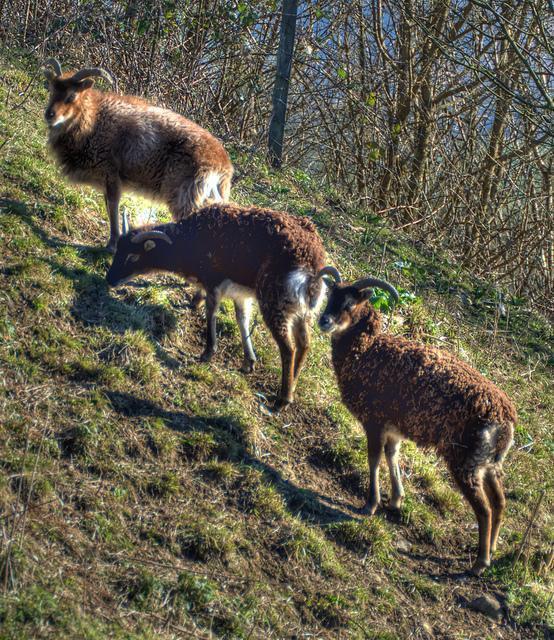How many goats do you see?
Give a very brief answer. 3. How many sheep are in the photo?
Give a very brief answer. 3. 